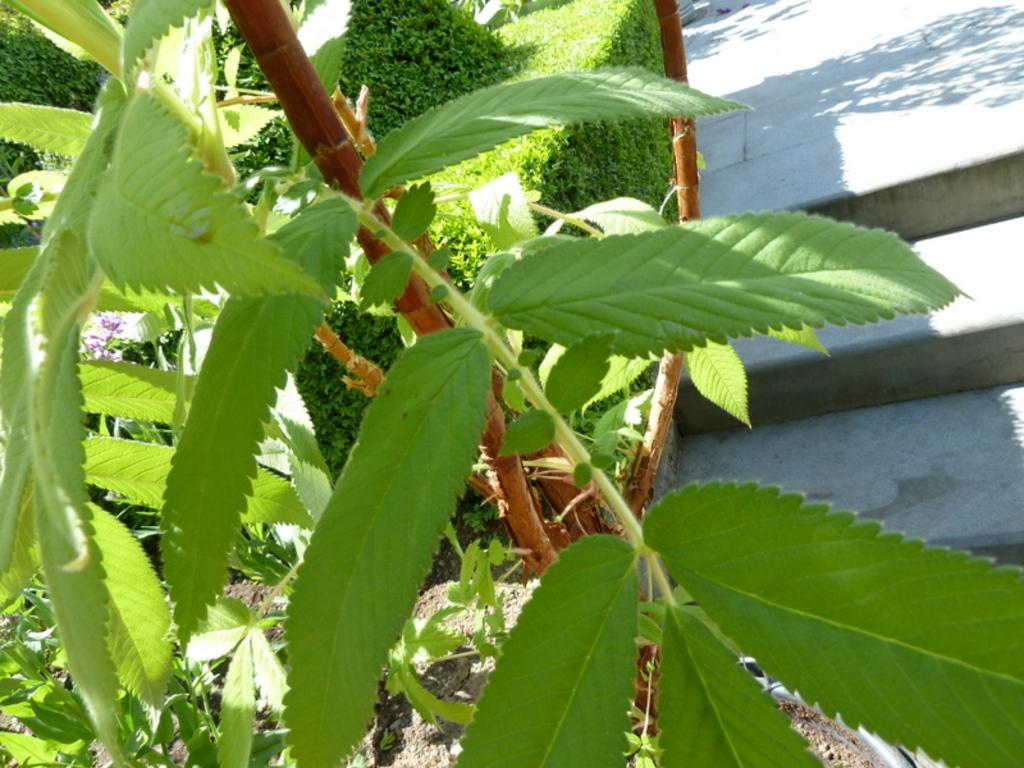What type of vegetation can be seen in the image? There are leaves in the image. What is the color of the leaves? The leaves are green in color. What architectural feature is visible in the background of the image? There are stairs in the background of the image. What else can be seen in the background of the image? There are plants in the background of the image. What hobbies are the leaves engaged in within the image? Leaves do not have hobbies, as they are inanimate objects. In which direction are the leaves facing in the image? The provided facts do not mention the direction the leaves are facing, so it cannot be determined from the image. 